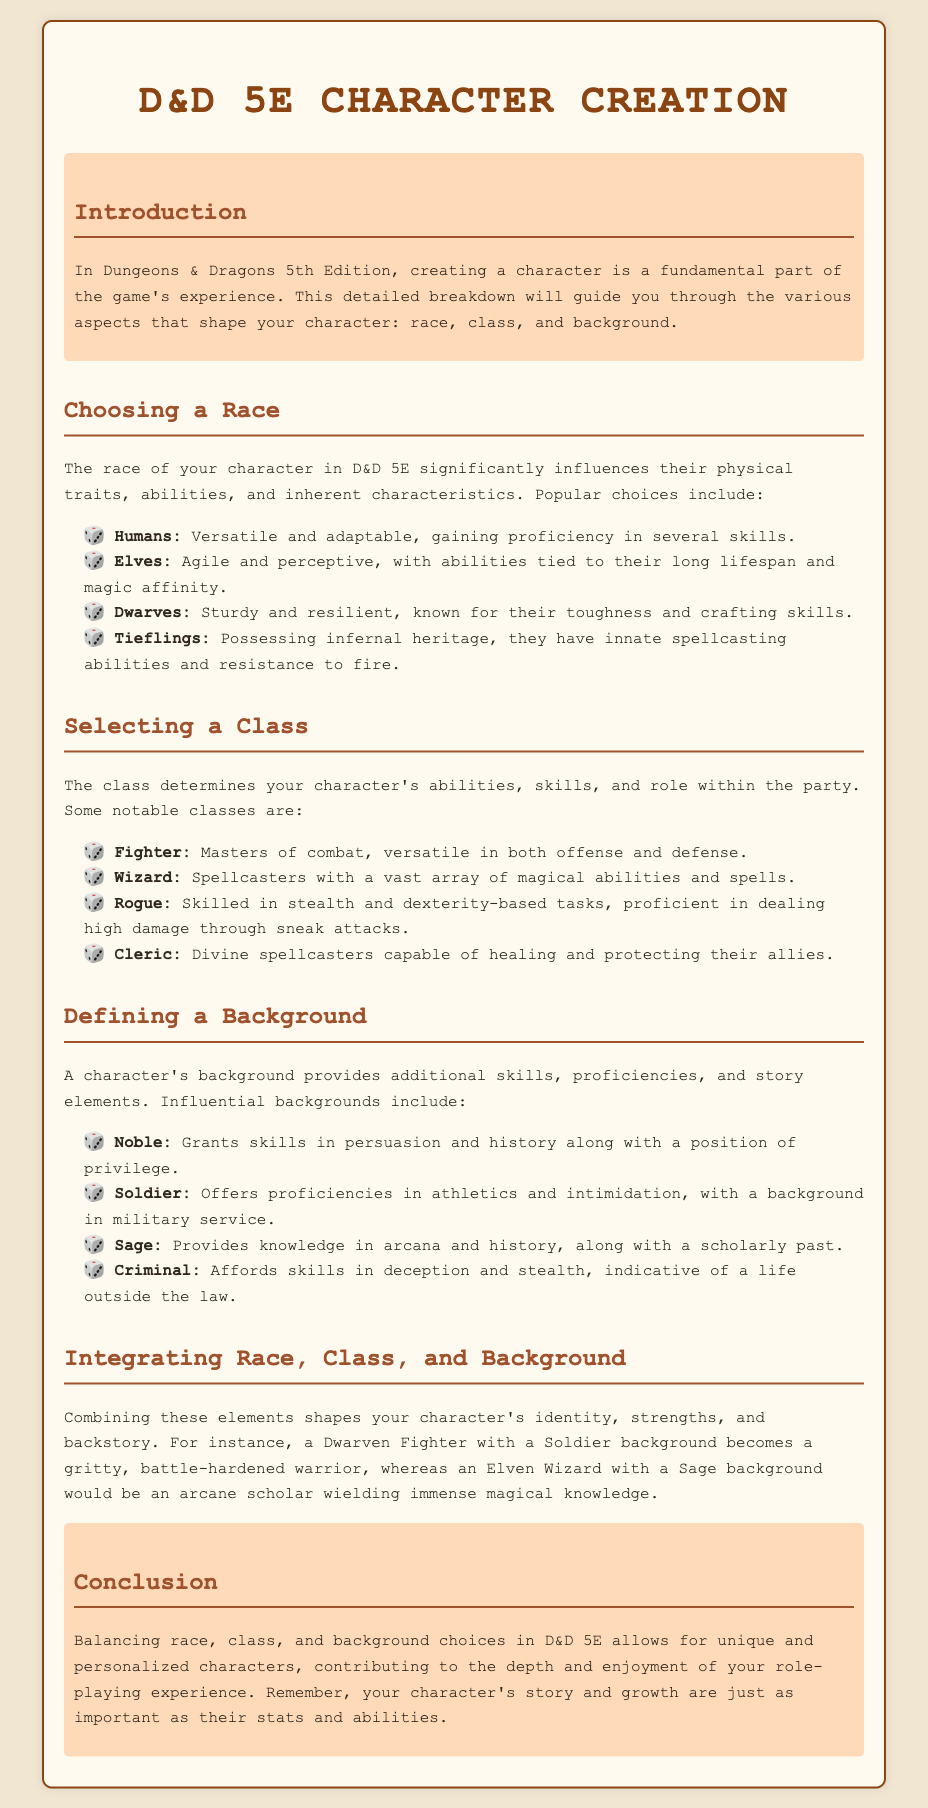What are the four popular races mentioned? The document lists four popular races: Humans, Elves, Dwarves, and Tieflings.
Answer: Humans, Elves, Dwarves, Tieflings What does the Fighter class excel in? According to the document, the Fighter class is masters of combat, versatile in both offense and defense.
Answer: Combat Which background affords skills in deception and stealth? The document states that the Criminal background grants skills in deception and stealth.
Answer: Criminal What influence does a character's background have? The document mentions that a character's background provides additional skills, proficiencies, and story elements.
Answer: Skills, proficiencies, story elements How can race, class, and background be integrated? The document explains that combining these elements shapes your character's identity, strengths, and backstory.
Answer: Identity, strengths, backstory What is the role of the Wizard class? The document describes the Wizard class as spellcasters with a vast array of magical abilities and spells.
Answer: Spellcasters How does a Dwarven Fighter with a Soldier background characterize? The document suggests that this combination results in a gritty, battle-hardened warrior.
Answer: Gritty, battle-hardened warrior Which race is known for innate spellcasting abilities? The document specifies that Tieflings possess innate spellcasting abilities.
Answer: Tieflings 